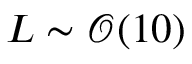<formula> <loc_0><loc_0><loc_500><loc_500>L \sim \mathcal { O } ( 1 0 )</formula> 